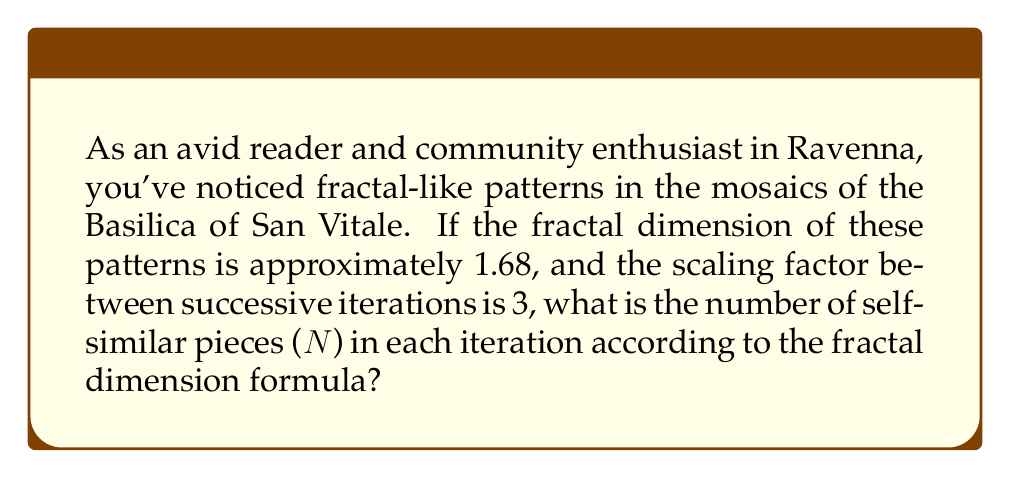Solve this math problem. Let's approach this step-by-step using the fractal dimension formula:

1. The fractal dimension formula is:
   $$D = \frac{\log N}{\log r}$$
   Where:
   $D$ is the fractal dimension
   $N$ is the number of self-similar pieces
   $r$ is the scaling factor

2. We're given:
   $D = 1.68$
   $r = 3$

3. Substituting these values into the formula:
   $$1.68 = \frac{\log N}{\log 3}$$

4. To solve for $N$, we can rearrange the equation:
   $$\log N = 1.68 \cdot \log 3$$

5. Now, we can use the exponential function to isolate $N$:
   $$N = e^{1.68 \cdot \log 3}$$

6. Using a calculator or computer:
   $$N \approx 5.0396$$

7. Since $N$ represents the number of self-similar pieces, it must be a whole number. We round to the nearest integer:
   $$N = 5$$

This means that in each iteration of the fractal pattern, there are approximately 5 self-similar pieces.
Answer: 5 